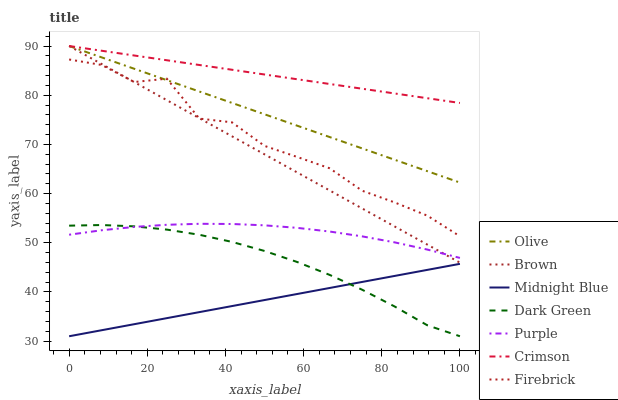Does Midnight Blue have the minimum area under the curve?
Answer yes or no. Yes. Does Crimson have the maximum area under the curve?
Answer yes or no. Yes. Does Purple have the minimum area under the curve?
Answer yes or no. No. Does Purple have the maximum area under the curve?
Answer yes or no. No. Is Olive the smoothest?
Answer yes or no. Yes. Is Firebrick the roughest?
Answer yes or no. Yes. Is Midnight Blue the smoothest?
Answer yes or no. No. Is Midnight Blue the roughest?
Answer yes or no. No. Does Midnight Blue have the lowest value?
Answer yes or no. Yes. Does Purple have the lowest value?
Answer yes or no. No. Does Olive have the highest value?
Answer yes or no. Yes. Does Purple have the highest value?
Answer yes or no. No. Is Dark Green less than Brown?
Answer yes or no. Yes. Is Crimson greater than Dark Green?
Answer yes or no. Yes. Does Firebrick intersect Brown?
Answer yes or no. Yes. Is Firebrick less than Brown?
Answer yes or no. No. Is Firebrick greater than Brown?
Answer yes or no. No. Does Dark Green intersect Brown?
Answer yes or no. No. 